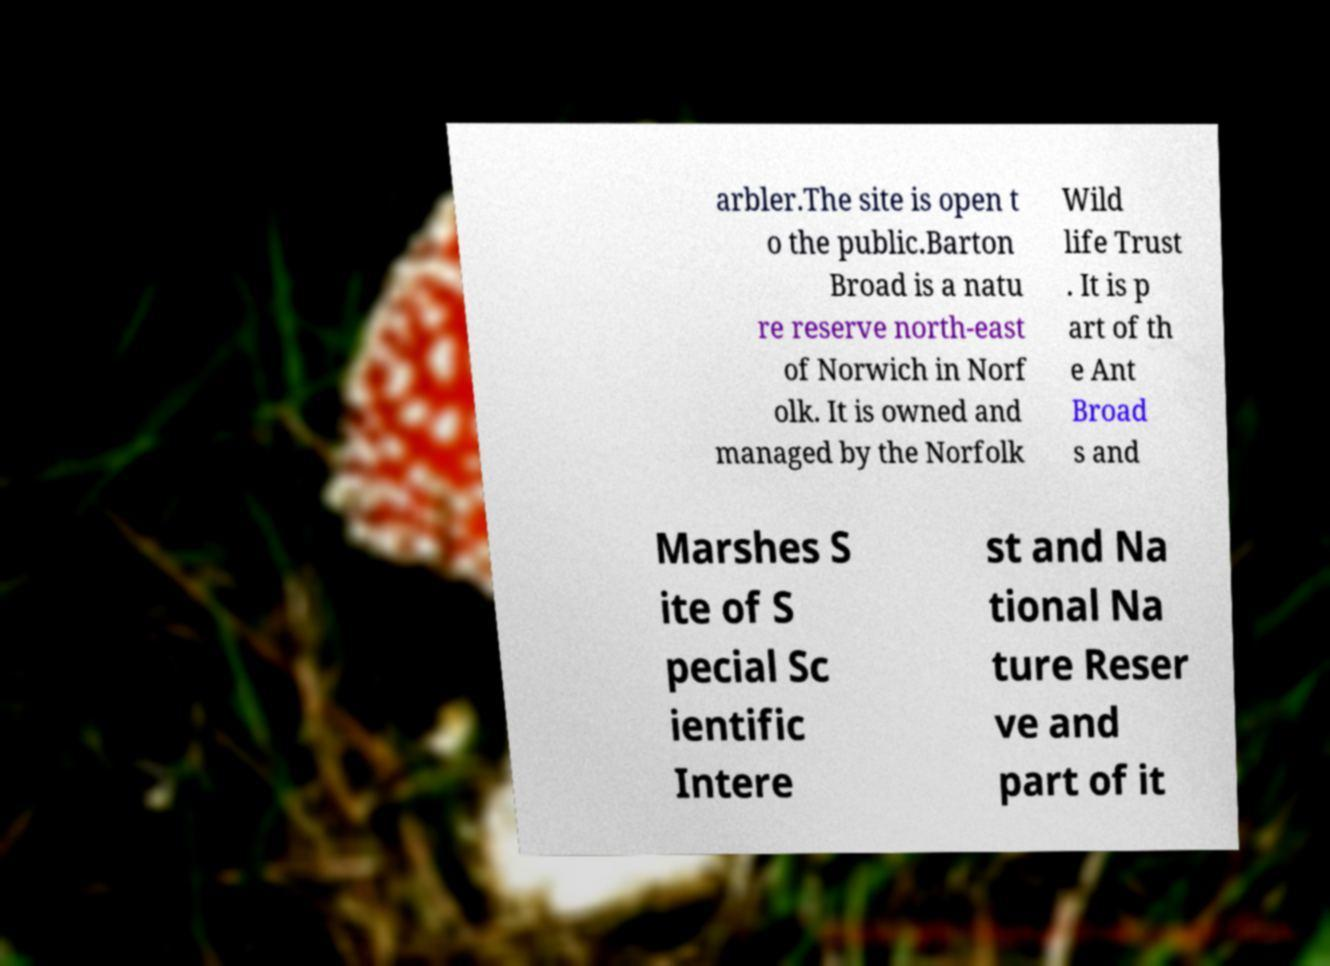Please read and relay the text visible in this image. What does it say? arbler.The site is open t o the public.Barton Broad is a natu re reserve north-east of Norwich in Norf olk. It is owned and managed by the Norfolk Wild life Trust . It is p art of th e Ant Broad s and Marshes S ite of S pecial Sc ientific Intere st and Na tional Na ture Reser ve and part of it 